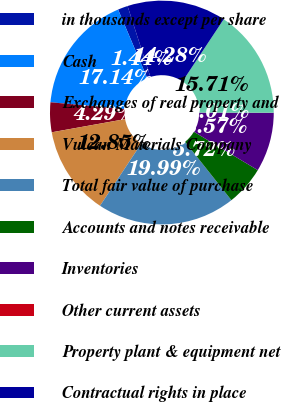Convert chart. <chart><loc_0><loc_0><loc_500><loc_500><pie_chart><fcel>in thousands except per share<fcel>Cash<fcel>Exchanges of real property and<fcel>Vulcan Materials Company<fcel>Total fair value of purchase<fcel>Accounts and notes receivable<fcel>Inventories<fcel>Other current assets<fcel>Property plant & equipment net<fcel>Contractual rights in place<nl><fcel>1.44%<fcel>17.14%<fcel>4.29%<fcel>12.85%<fcel>19.99%<fcel>5.72%<fcel>8.57%<fcel>0.01%<fcel>15.71%<fcel>14.28%<nl></chart> 